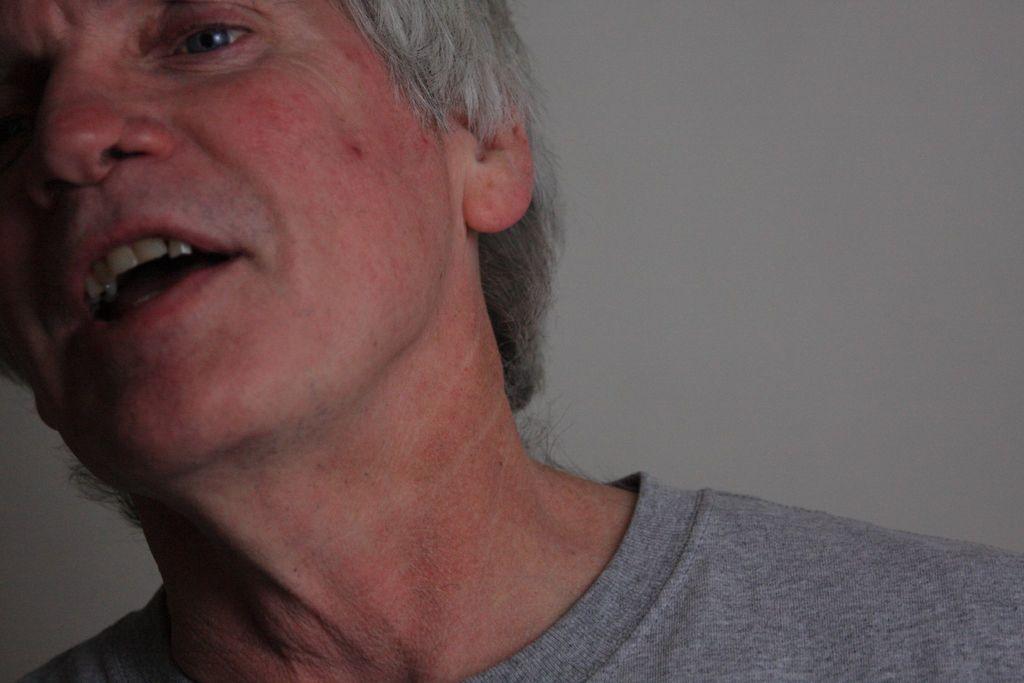Could you give a brief overview of what you see in this image? In this image we can see a person with gray hair and some part of the head has been truncated. 